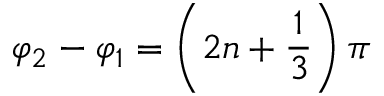<formula> <loc_0><loc_0><loc_500><loc_500>\varphi _ { 2 } - \varphi _ { 1 } = \left ( 2 n + \frac { 1 } { 3 } \right ) \pi</formula> 